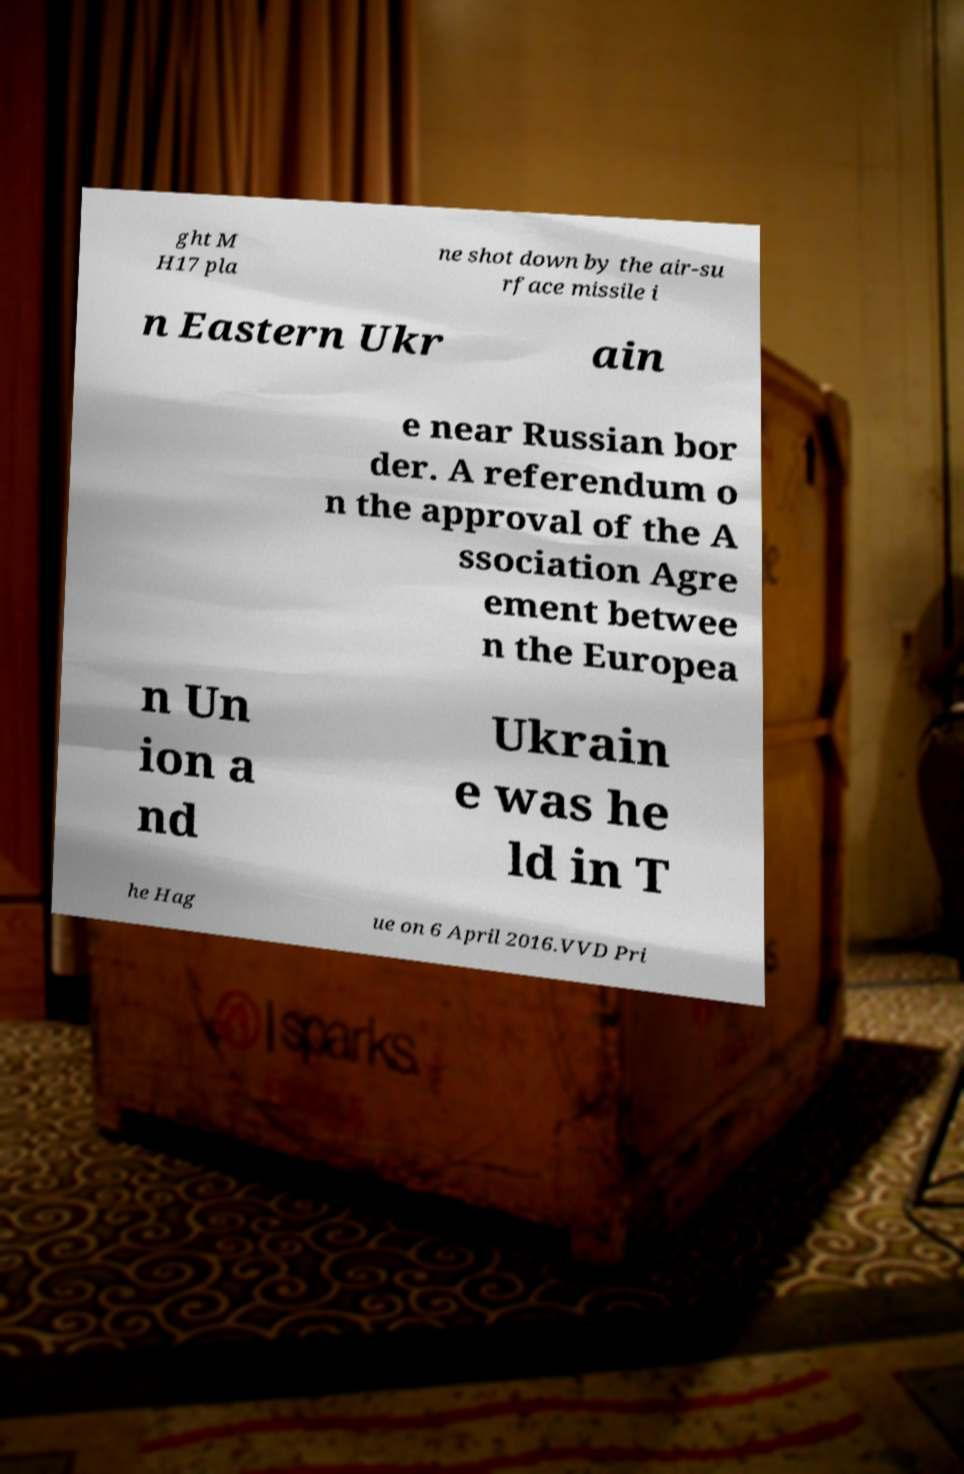For documentation purposes, I need the text within this image transcribed. Could you provide that? ght M H17 pla ne shot down by the air-su rface missile i n Eastern Ukr ain e near Russian bor der. A referendum o n the approval of the A ssociation Agre ement betwee n the Europea n Un ion a nd Ukrain e was he ld in T he Hag ue on 6 April 2016.VVD Pri 